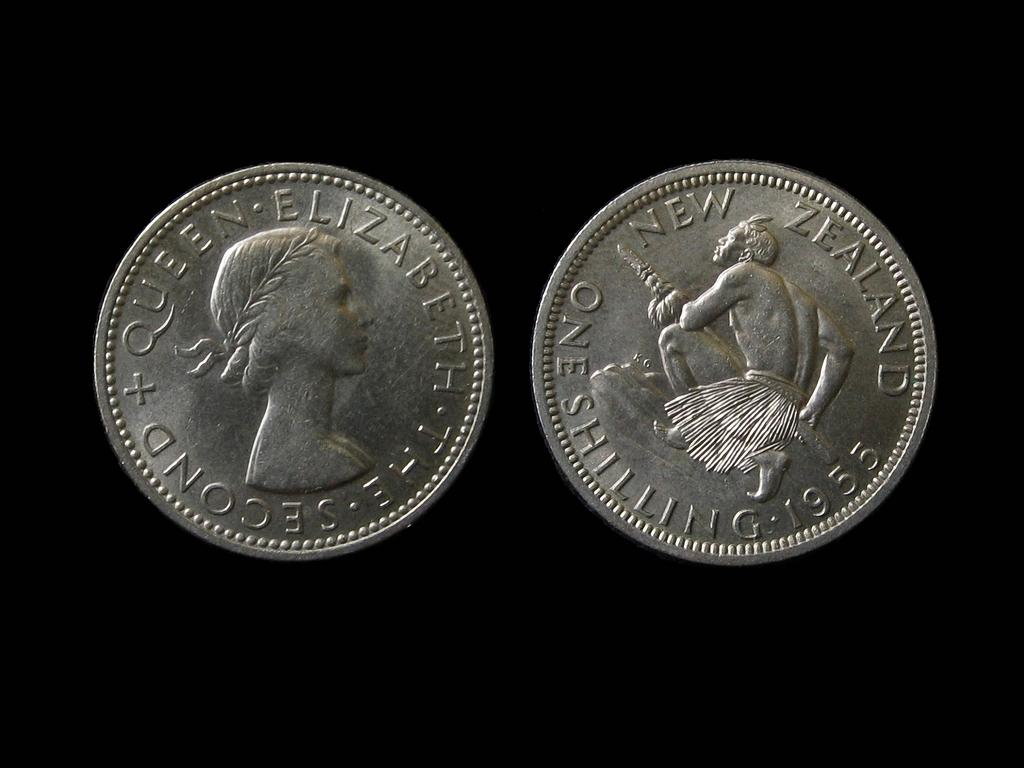<image>
Give a short and clear explanation of the subsequent image. the front and back view of a new zeland one shilling 1955 coin 